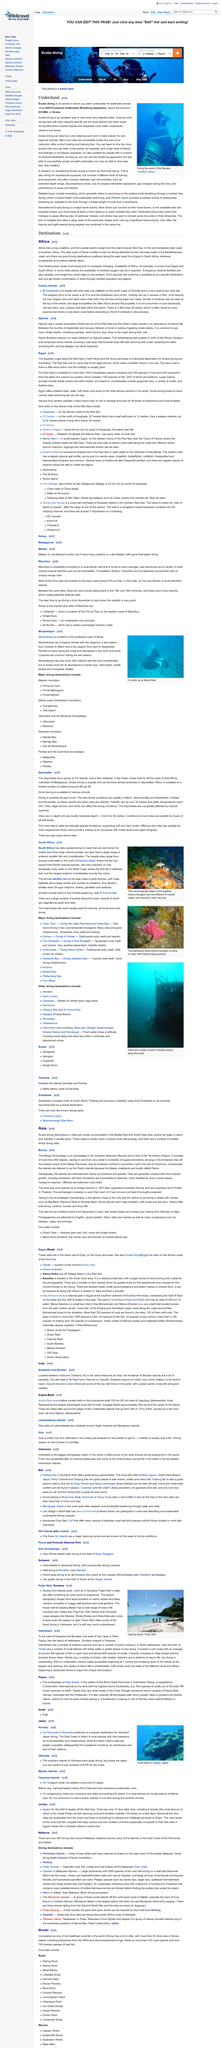Specify some key components in this picture. The article is discussing the continent of Africa. The Zenobia shipwreck in Lamaca, Cyprus is a popular diving attraction. The East Coast of Africa is more well-known for its diving destinations than the West Coast. SCUBA diving is suitable for beginners. Divers can enjoy the underwater world of the Seychelles all year round as the destination offers great diving opportunities all year round. 